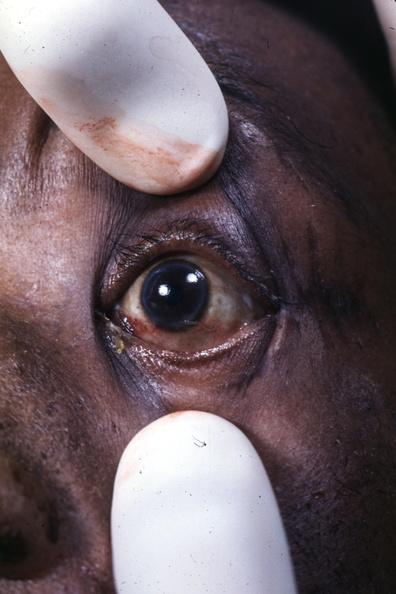s arcus senilis present?
Answer the question using a single word or phrase. Yes 